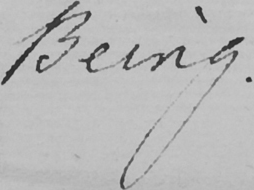Can you read and transcribe this handwriting? Being . 